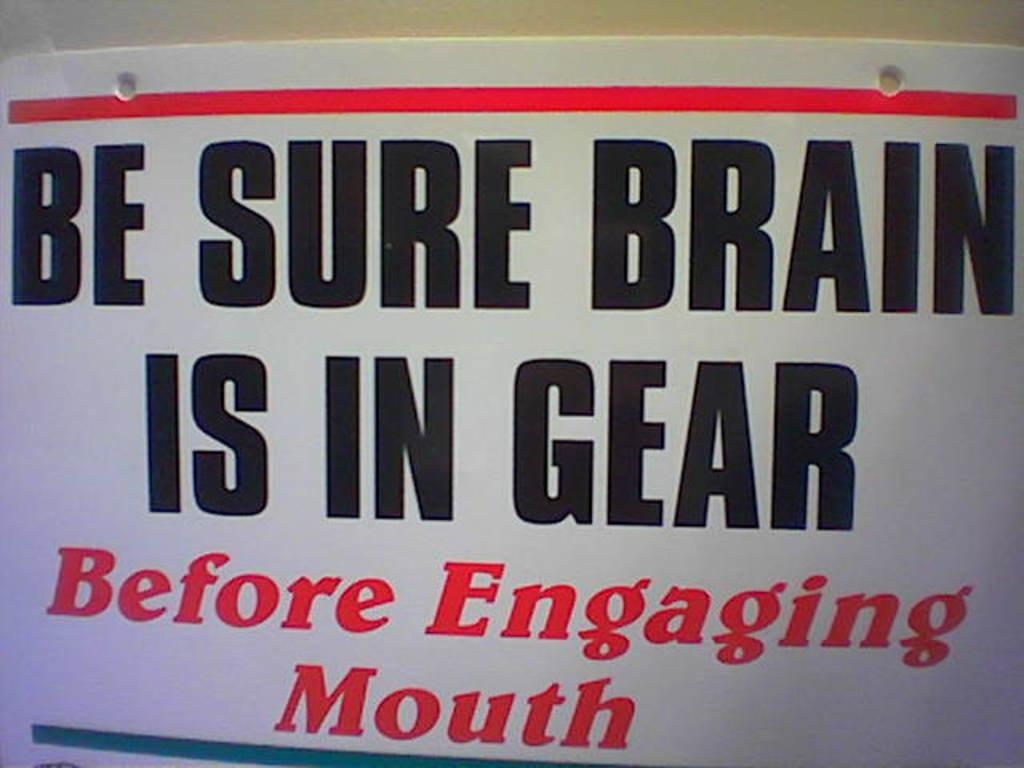Provide a one-sentence caption for the provided image. a sign that says be sure brain is in gear. 